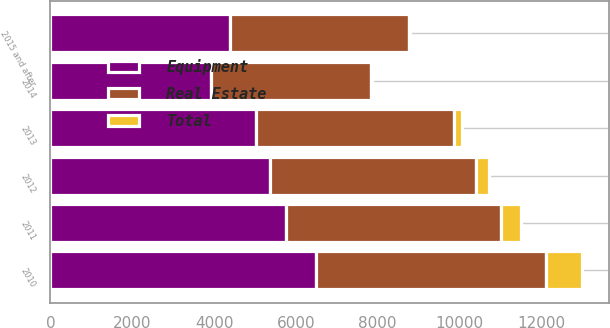Convert chart to OTSL. <chart><loc_0><loc_0><loc_500><loc_500><stacked_bar_chart><ecel><fcel>2010<fcel>2011<fcel>2012<fcel>2013<fcel>2014<fcel>2015 and after<nl><fcel>Real Estate<fcel>5608<fcel>5256<fcel>5046<fcel>4837<fcel>3905<fcel>4385.5<nl><fcel>Total<fcel>888<fcel>491<fcel>312<fcel>195<fcel>29<fcel>8<nl><fcel>Equipment<fcel>6496<fcel>5747<fcel>5358<fcel>5032<fcel>3934<fcel>4385.5<nl></chart> 